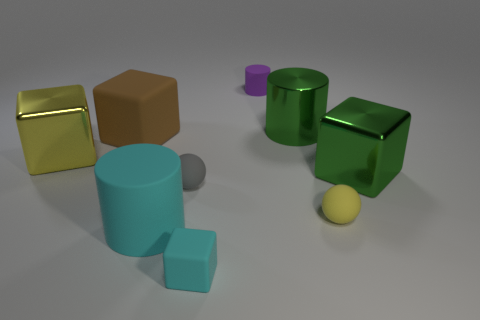Subtract all yellow blocks. How many blocks are left? 3 Subtract all yellow metal cubes. How many cubes are left? 3 Add 1 big green cylinders. How many objects exist? 10 Subtract all green cylinders. Subtract all red balls. How many cylinders are left? 2 Subtract all gray spheres. How many cyan cubes are left? 1 Add 3 large objects. How many large objects are left? 8 Add 1 things. How many things exist? 10 Subtract 0 red balls. How many objects are left? 9 Subtract all cubes. How many objects are left? 5 Subtract 2 cylinders. How many cylinders are left? 1 